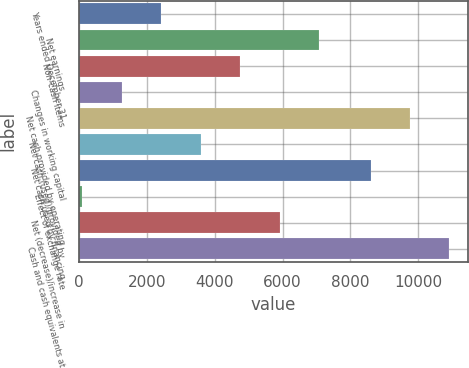Convert chart. <chart><loc_0><loc_0><loc_500><loc_500><bar_chart><fcel>Years ended December 31<fcel>Net earnings<fcel>Non-cash items<fcel>Changes in working capital<fcel>Net cash provided by operating<fcel>Net cash (used)/provided by<fcel>Net cash used by financing<fcel>Effect of exchange rate<fcel>Net (decrease)/increase in<fcel>Cash and cash equivalents at<nl><fcel>2416.2<fcel>7074.6<fcel>4745.4<fcel>1251.6<fcel>9757.6<fcel>3580.8<fcel>8593<fcel>87<fcel>5910<fcel>10922.2<nl></chart> 